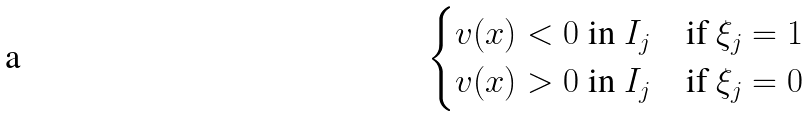<formula> <loc_0><loc_0><loc_500><loc_500>\begin{cases} v ( x ) < 0 \ \text {in} \ I _ { j } & \text {if} \ \xi _ { j } = 1 \\ v ( x ) > 0 \ \text {in} \ I _ { j } & \text {if} \ \xi _ { j } = 0 \end{cases}</formula> 